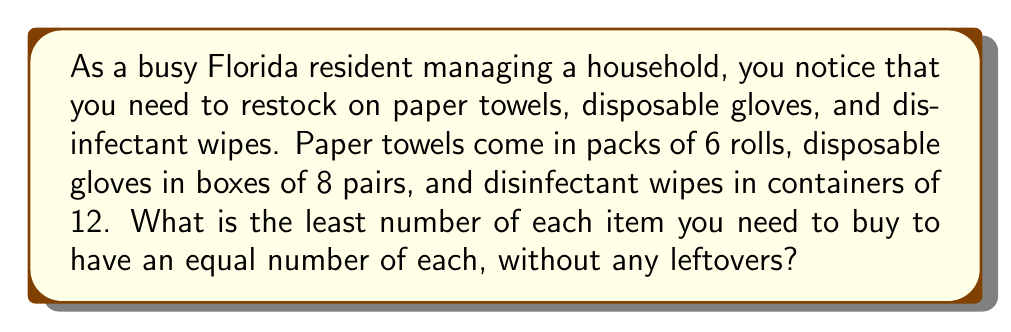Teach me how to tackle this problem. To solve this problem, we need to find the least common multiple (LCM) of 6, 8, and 12. Let's break it down step-by-step:

1. First, let's find the prime factorization of each number:
   $6 = 2 \times 3$
   $8 = 2^3$
   $12 = 2^2 \times 3$

2. The LCM will include the highest power of each prime factor from these numbers:
   $LCM = 2^3 \times 3$

3. Calculate the result:
   $LCM = 8 \times 3 = 24$

This means you need to buy:
- 4 packs of paper towels (6 × 4 = 24 rolls)
- 3 boxes of disposable gloves (8 × 3 = 24 pairs)
- 2 containers of disinfectant wipes (12 × 2 = 24 wipes)

To verify:
$$ \frac{24}{6} = 4 \text{ (paper towel packs)} $$
$$ \frac{24}{8} = 3 \text{ (glove boxes)} $$
$$ \frac{24}{12} = 2 \text{ (wipe containers)} $$

This solution ensures you have an equal number of each item (24) without any leftovers, which is efficient for a busy household.
Answer: 24 of each item 